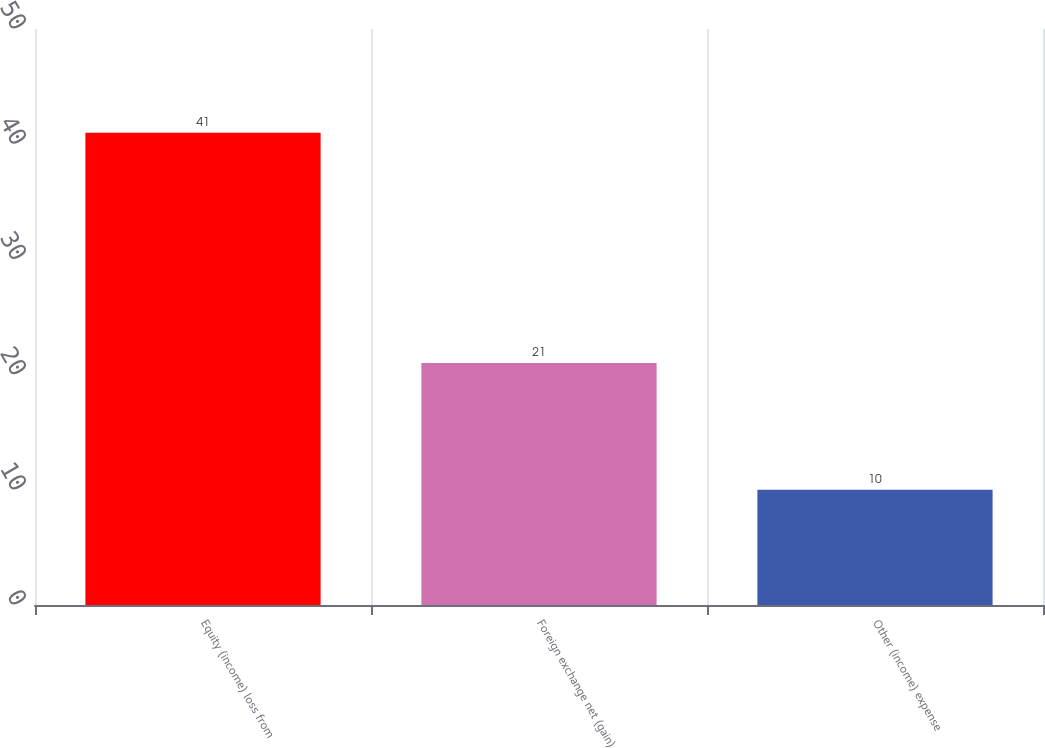<chart> <loc_0><loc_0><loc_500><loc_500><bar_chart><fcel>Equity (income) loss from<fcel>Foreign exchange net (gain)<fcel>Other (income) expense<nl><fcel>41<fcel>21<fcel>10<nl></chart> 